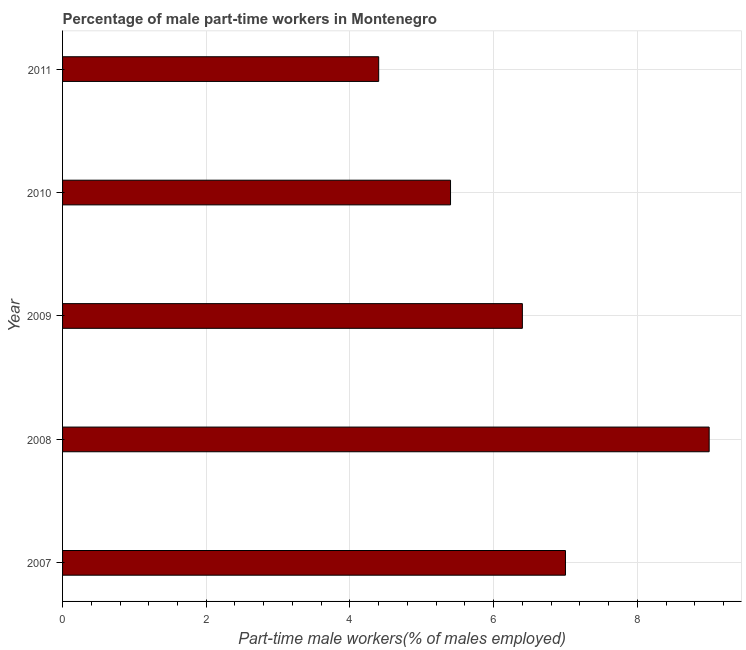Does the graph contain any zero values?
Ensure brevity in your answer.  No. Does the graph contain grids?
Make the answer very short. Yes. What is the title of the graph?
Provide a short and direct response. Percentage of male part-time workers in Montenegro. What is the label or title of the X-axis?
Your response must be concise. Part-time male workers(% of males employed). What is the label or title of the Y-axis?
Make the answer very short. Year. What is the percentage of part-time male workers in 2007?
Offer a very short reply. 7. Across all years, what is the minimum percentage of part-time male workers?
Ensure brevity in your answer.  4.4. In which year was the percentage of part-time male workers minimum?
Offer a very short reply. 2011. What is the sum of the percentage of part-time male workers?
Offer a very short reply. 32.2. What is the difference between the percentage of part-time male workers in 2007 and 2008?
Your answer should be very brief. -2. What is the average percentage of part-time male workers per year?
Give a very brief answer. 6.44. What is the median percentage of part-time male workers?
Give a very brief answer. 6.4. Do a majority of the years between 2011 and 2010 (inclusive) have percentage of part-time male workers greater than 7.2 %?
Provide a succinct answer. No. What is the ratio of the percentage of part-time male workers in 2010 to that in 2011?
Your answer should be compact. 1.23. Is the percentage of part-time male workers in 2009 less than that in 2011?
Give a very brief answer. No. Is the difference between the percentage of part-time male workers in 2007 and 2010 greater than the difference between any two years?
Provide a succinct answer. No. What is the difference between the highest and the lowest percentage of part-time male workers?
Make the answer very short. 4.6. In how many years, is the percentage of part-time male workers greater than the average percentage of part-time male workers taken over all years?
Offer a terse response. 2. What is the difference between two consecutive major ticks on the X-axis?
Keep it short and to the point. 2. What is the Part-time male workers(% of males employed) in 2008?
Your answer should be very brief. 9. What is the Part-time male workers(% of males employed) of 2009?
Your answer should be compact. 6.4. What is the Part-time male workers(% of males employed) of 2010?
Make the answer very short. 5.4. What is the Part-time male workers(% of males employed) in 2011?
Provide a succinct answer. 4.4. What is the difference between the Part-time male workers(% of males employed) in 2007 and 2009?
Make the answer very short. 0.6. What is the difference between the Part-time male workers(% of males employed) in 2007 and 2010?
Provide a short and direct response. 1.6. What is the difference between the Part-time male workers(% of males employed) in 2007 and 2011?
Provide a short and direct response. 2.6. What is the difference between the Part-time male workers(% of males employed) in 2008 and 2009?
Provide a succinct answer. 2.6. What is the difference between the Part-time male workers(% of males employed) in 2009 and 2010?
Offer a very short reply. 1. What is the difference between the Part-time male workers(% of males employed) in 2010 and 2011?
Keep it short and to the point. 1. What is the ratio of the Part-time male workers(% of males employed) in 2007 to that in 2008?
Your answer should be compact. 0.78. What is the ratio of the Part-time male workers(% of males employed) in 2007 to that in 2009?
Provide a short and direct response. 1.09. What is the ratio of the Part-time male workers(% of males employed) in 2007 to that in 2010?
Ensure brevity in your answer.  1.3. What is the ratio of the Part-time male workers(% of males employed) in 2007 to that in 2011?
Give a very brief answer. 1.59. What is the ratio of the Part-time male workers(% of males employed) in 2008 to that in 2009?
Provide a succinct answer. 1.41. What is the ratio of the Part-time male workers(% of males employed) in 2008 to that in 2010?
Provide a succinct answer. 1.67. What is the ratio of the Part-time male workers(% of males employed) in 2008 to that in 2011?
Give a very brief answer. 2.04. What is the ratio of the Part-time male workers(% of males employed) in 2009 to that in 2010?
Your answer should be very brief. 1.19. What is the ratio of the Part-time male workers(% of males employed) in 2009 to that in 2011?
Provide a short and direct response. 1.46. What is the ratio of the Part-time male workers(% of males employed) in 2010 to that in 2011?
Your response must be concise. 1.23. 